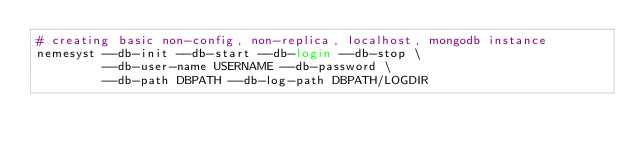Convert code to text. <code><loc_0><loc_0><loc_500><loc_500><_Bash_># creating basic non-config, non-replica, localhost, mongodb instance
nemesyst --db-init --db-start --db-login --db-stop \
         --db-user-name USERNAME --db-password \
         --db-path DBPATH --db-log-path DBPATH/LOGDIR
</code> 